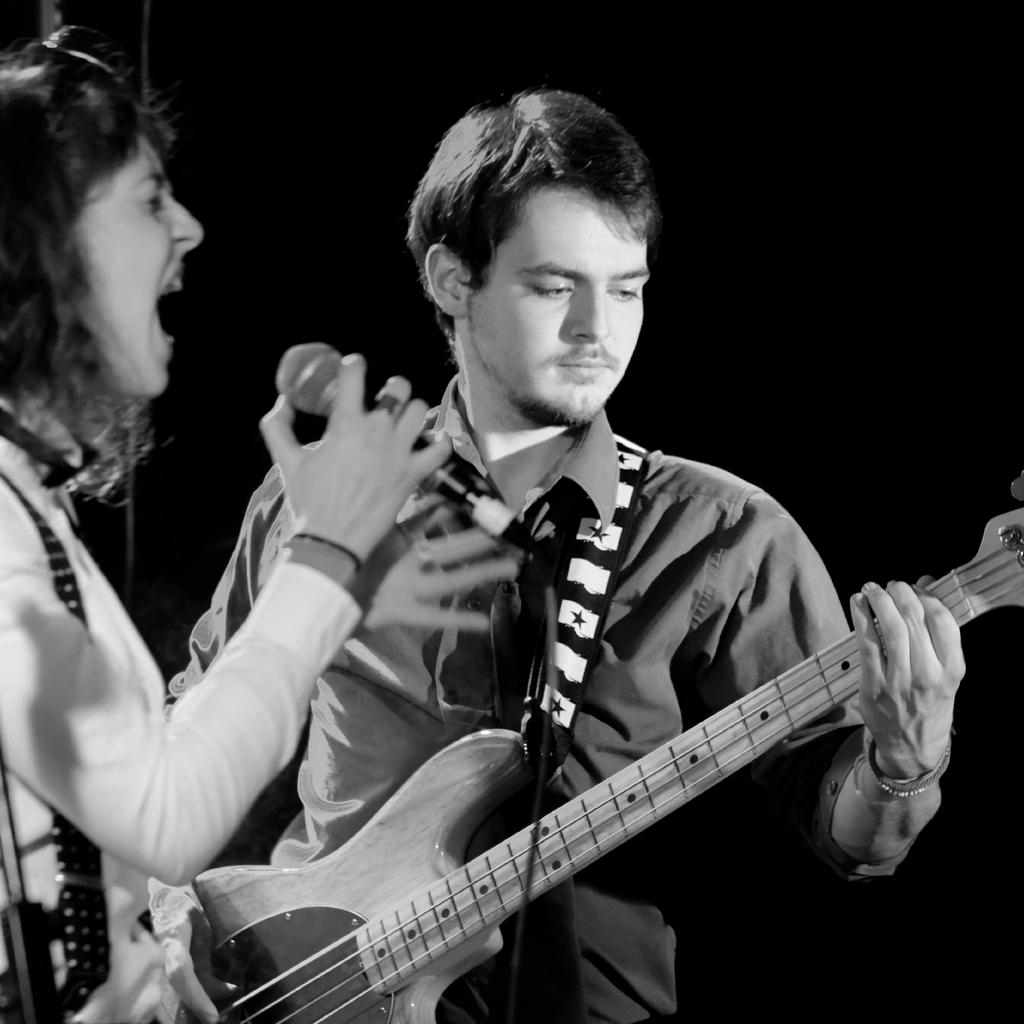What is the man in the image holding? The man is holding a guitar. What is the woman in the image holding? The woman is holding a microphone. Can you describe the interaction between the man and the woman in the image? The man and the woman are likely performing together, as the man is holding a guitar and the woman is holding a microphone. What type of flower can be seen growing near the cannon in the image? There is no flower or cannon present in the image; it features a man holding a guitar and a woman holding a microphone. 